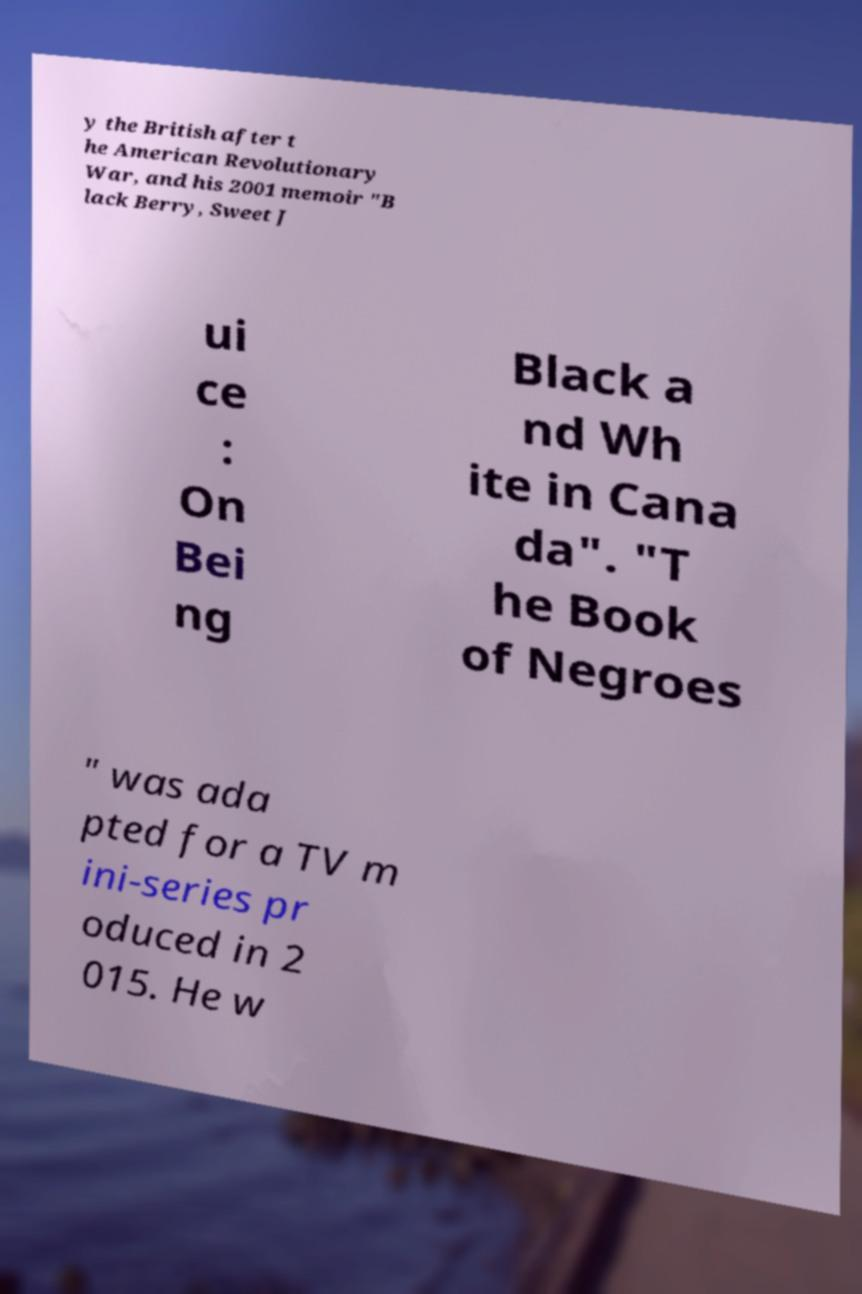Could you assist in decoding the text presented in this image and type it out clearly? y the British after t he American Revolutionary War, and his 2001 memoir "B lack Berry, Sweet J ui ce : On Bei ng Black a nd Wh ite in Cana da". "T he Book of Negroes " was ada pted for a TV m ini-series pr oduced in 2 015. He w 